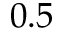<formula> <loc_0><loc_0><loc_500><loc_500>0 . 5</formula> 